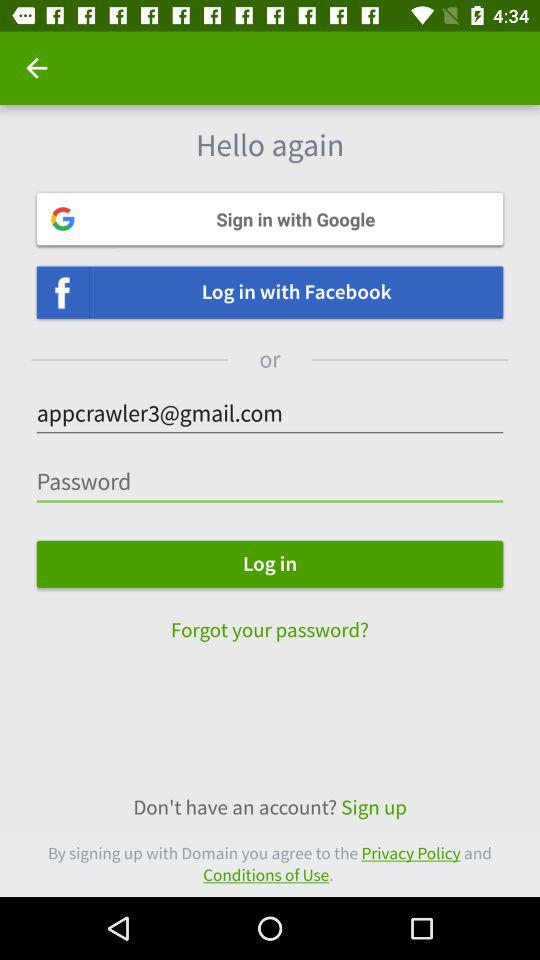Through what application can we log in with? You can log in with "Google" and "Facebook". 